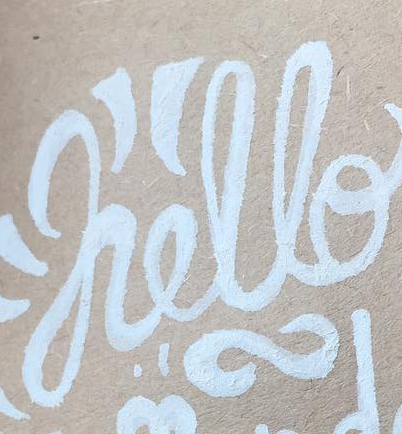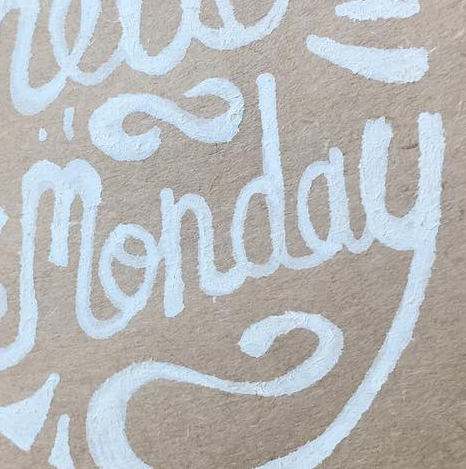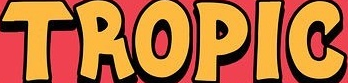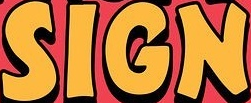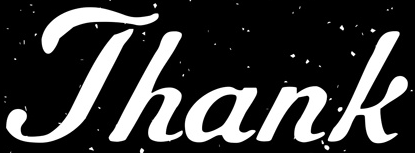What words can you see in these images in sequence, separated by a semicolon? hello; monday; TROPIC; SIGN; Thank 